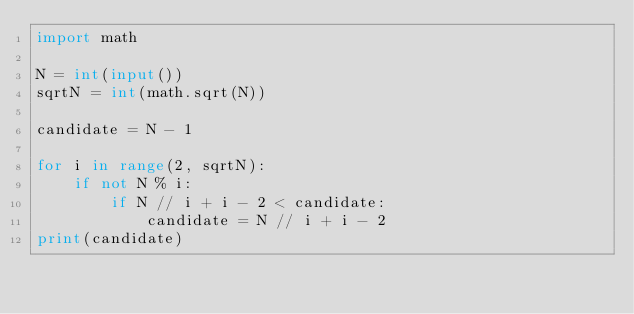Convert code to text. <code><loc_0><loc_0><loc_500><loc_500><_Python_>import math

N = int(input())
sqrtN = int(math.sqrt(N))

candidate = N - 1

for i in range(2, sqrtN):
    if not N % i:
        if N // i + i - 2 < candidate:
            candidate = N // i + i - 2
print(candidate)
</code> 